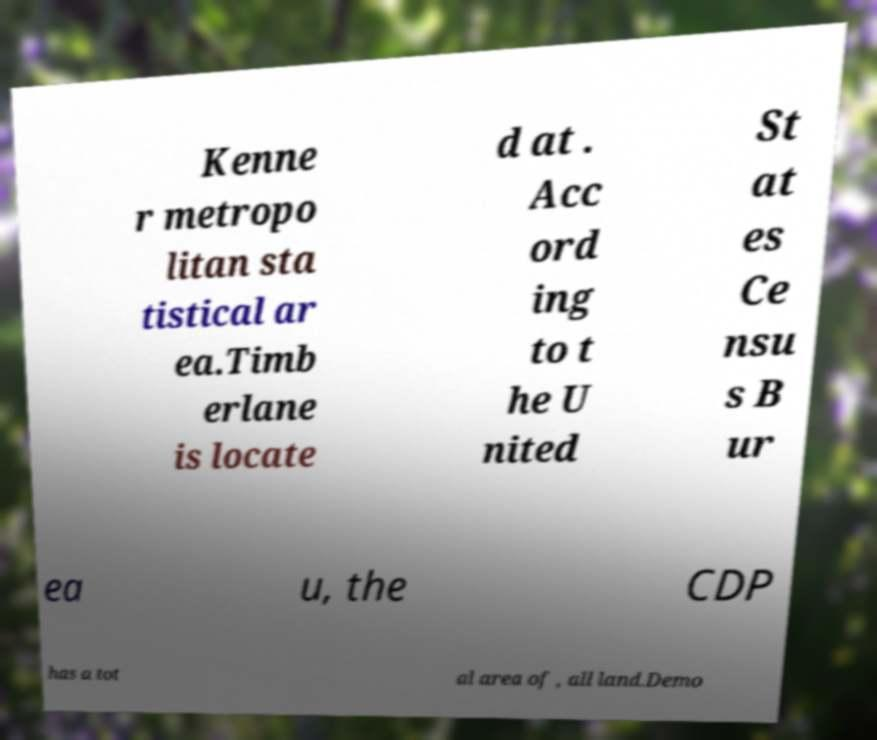For documentation purposes, I need the text within this image transcribed. Could you provide that? Kenne r metropo litan sta tistical ar ea.Timb erlane is locate d at . Acc ord ing to t he U nited St at es Ce nsu s B ur ea u, the CDP has a tot al area of , all land.Demo 